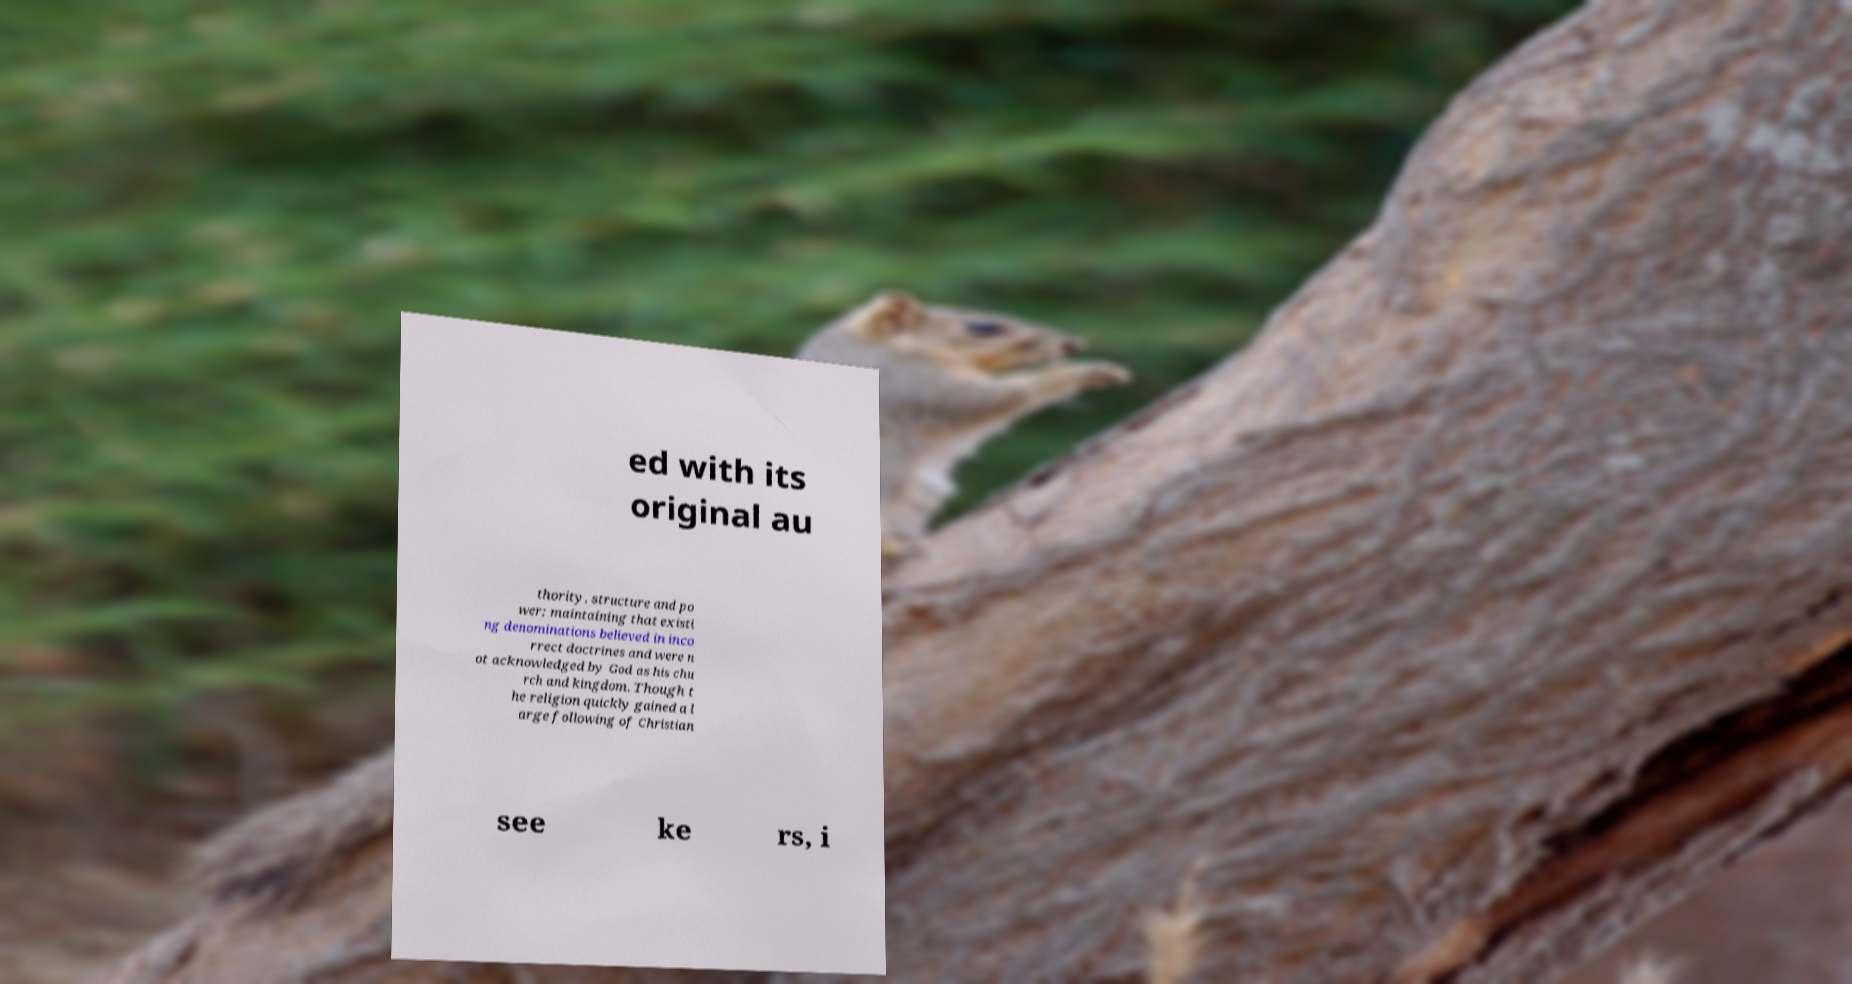There's text embedded in this image that I need extracted. Can you transcribe it verbatim? ed with its original au thority, structure and po wer; maintaining that existi ng denominations believed in inco rrect doctrines and were n ot acknowledged by God as his chu rch and kingdom. Though t he religion quickly gained a l arge following of Christian see ke rs, i 